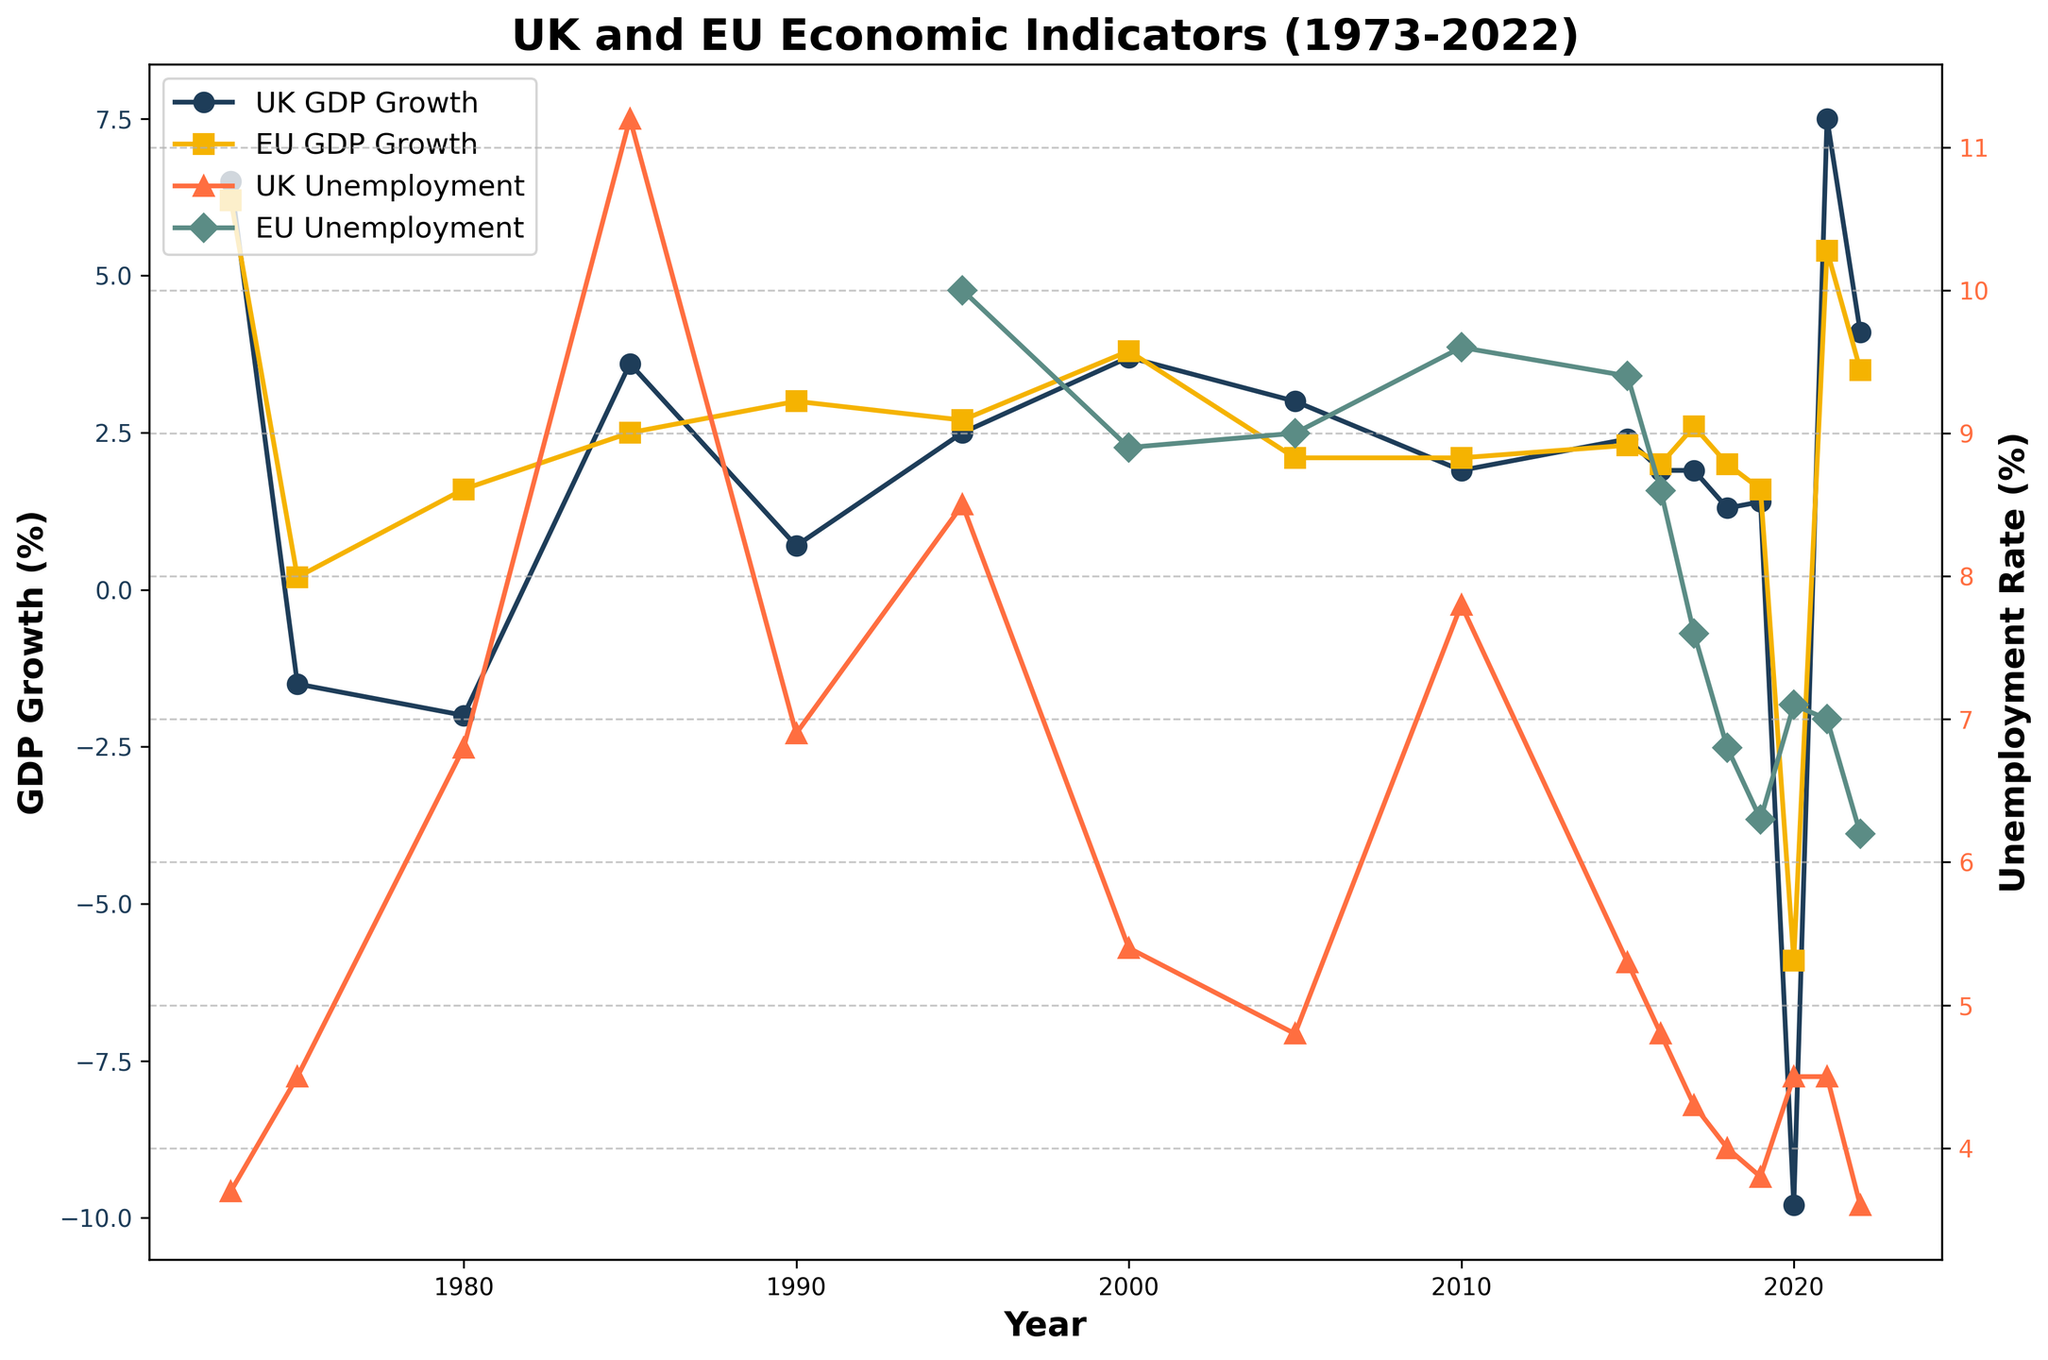What were the GDP growth rates for the UK and EU in 1980? Looking at the data points for the year 1980, we find that the UK GDP growth is -2.0% and the EU GDP growth is 1.6%.
Answer: UK: -2.0%, EU: 1.6% Between 2000 and 2010, did the UK's unemployment rate ever surpass that of the EU? Examining the unemployment rate for both the UK and EU between 2000 and 2010, the UK's unemployment rate is never higher than the EU's during this period.
Answer: No Which year had the highest GDP growth rate for the UK from 1973 to 2022? Reviewing the chart for UK's GDP growth rates from 1973 to 2022, the highest rate occurred in 2021 at 7.5%.
Answer: 2021 How did the unemployment rates in the UK and EU compare in 2005? In 2005, the chart shows the UK's unemployment rate at 4.8% and the EU's at 9.0%, indicating that the EU had a higher unemployment rate.
Answer: EU had higher What is the difference in GDP growth between the UK and EU in 2020? In 2020, the UK had a GDP growth of -9.8% and the EU had -5.9%. The difference is -9.8% - (-5.9%) = -3.9%. This means the UK's GDP declined more drastically.
Answer: -3.9% What trends can be observed in the unemployment rates for the UK from 1973 to 2022? From the chart, the UK's unemployment rate starts at about 3.7% in 1973, increases to a peak of 11.2% in 1985, then generally declines with minor fluctuations to around 3.6% by 2022.
Answer: Increasing to peak in 1985, then decreasing In which year did the UK and EU both experience negative GDP growth? Observing the chart, both the UK and EU had negative GDP growth in 2020.
Answer: 2020 How did the UK’s GDP growth in 1995 compare to 1990? In 1995, the UK's GDP growth was 2.5%, while in 1990, it was 0.7%. Thus, the GDP growth was higher in 1995 compared to 1990.
Answer: Higher in 1995 